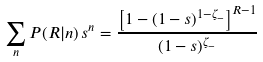Convert formula to latex. <formula><loc_0><loc_0><loc_500><loc_500>\sum _ { n } P ( R | n ) \, s ^ { n } = \frac { \left [ 1 - ( 1 - s ) ^ { 1 - \zeta _ { - } } \right ] ^ { R - 1 } } { ( 1 - s ) ^ { \zeta _ { - } } }</formula> 